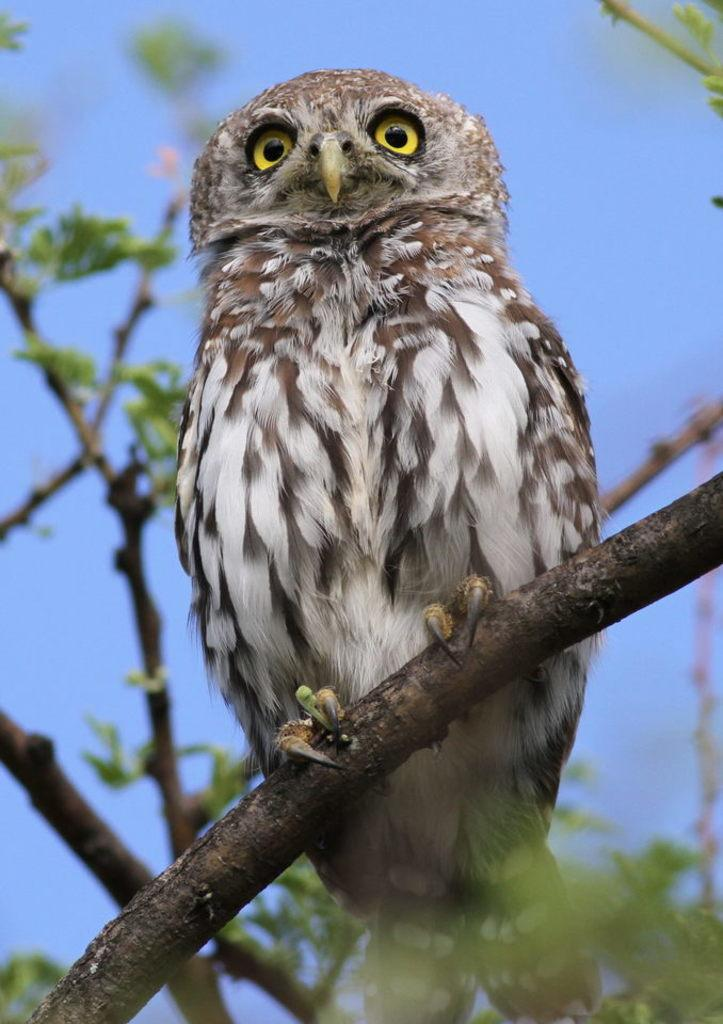What animal is present in the image? There is an owl in the image. Where is the owl located? The owl is on the branch of a tree. What can be seen in the background of the image? There is sky visible in the background of the image. Is there a stream running through the cemetery in the image? There is no cemetery or stream present in the image; it features an owl on a tree branch with sky visible in the background. 